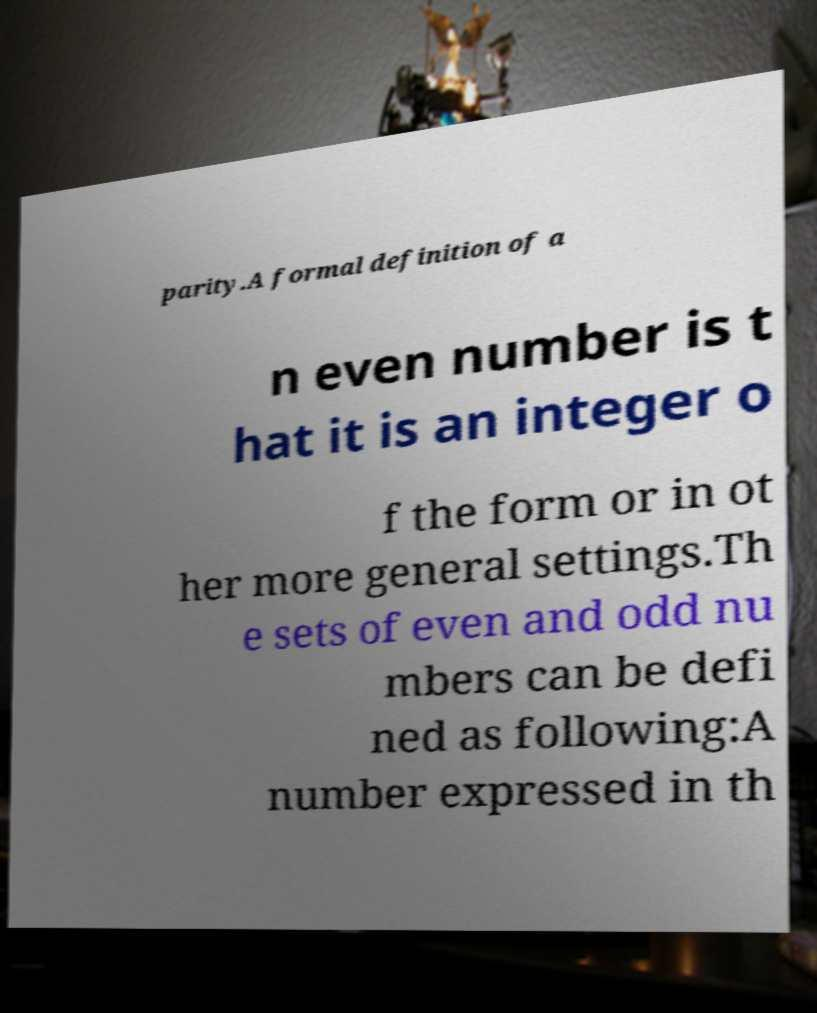For documentation purposes, I need the text within this image transcribed. Could you provide that? parity.A formal definition of a n even number is t hat it is an integer o f the form or in ot her more general settings.Th e sets of even and odd nu mbers can be defi ned as following:A number expressed in th 